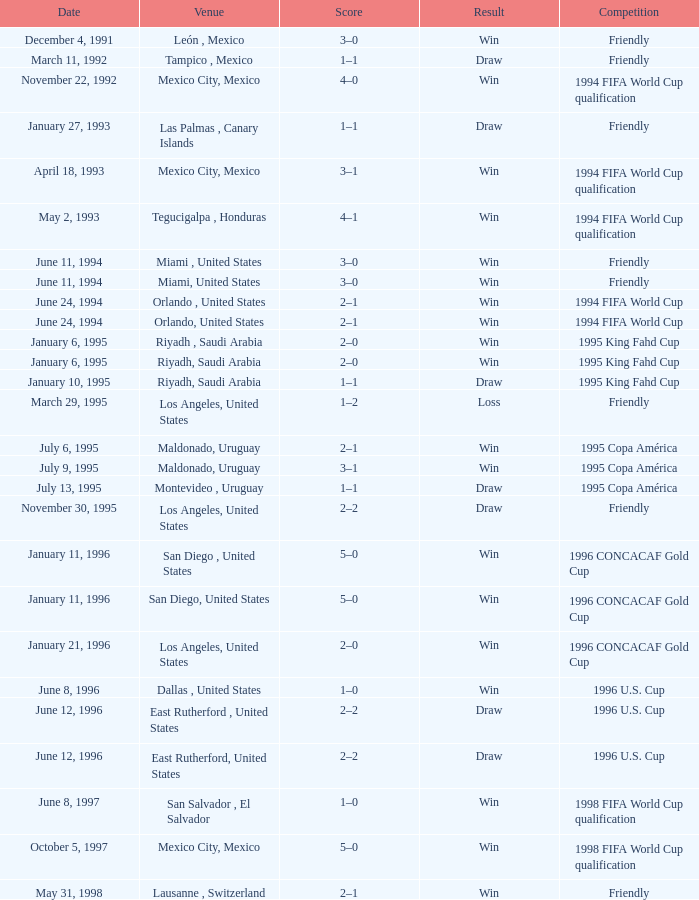What is Competition, when Date is "January 11, 1996", when Venue is "San Diego , United States"? 1996 CONCACAF Gold Cup, 1996 CONCACAF Gold Cup. 